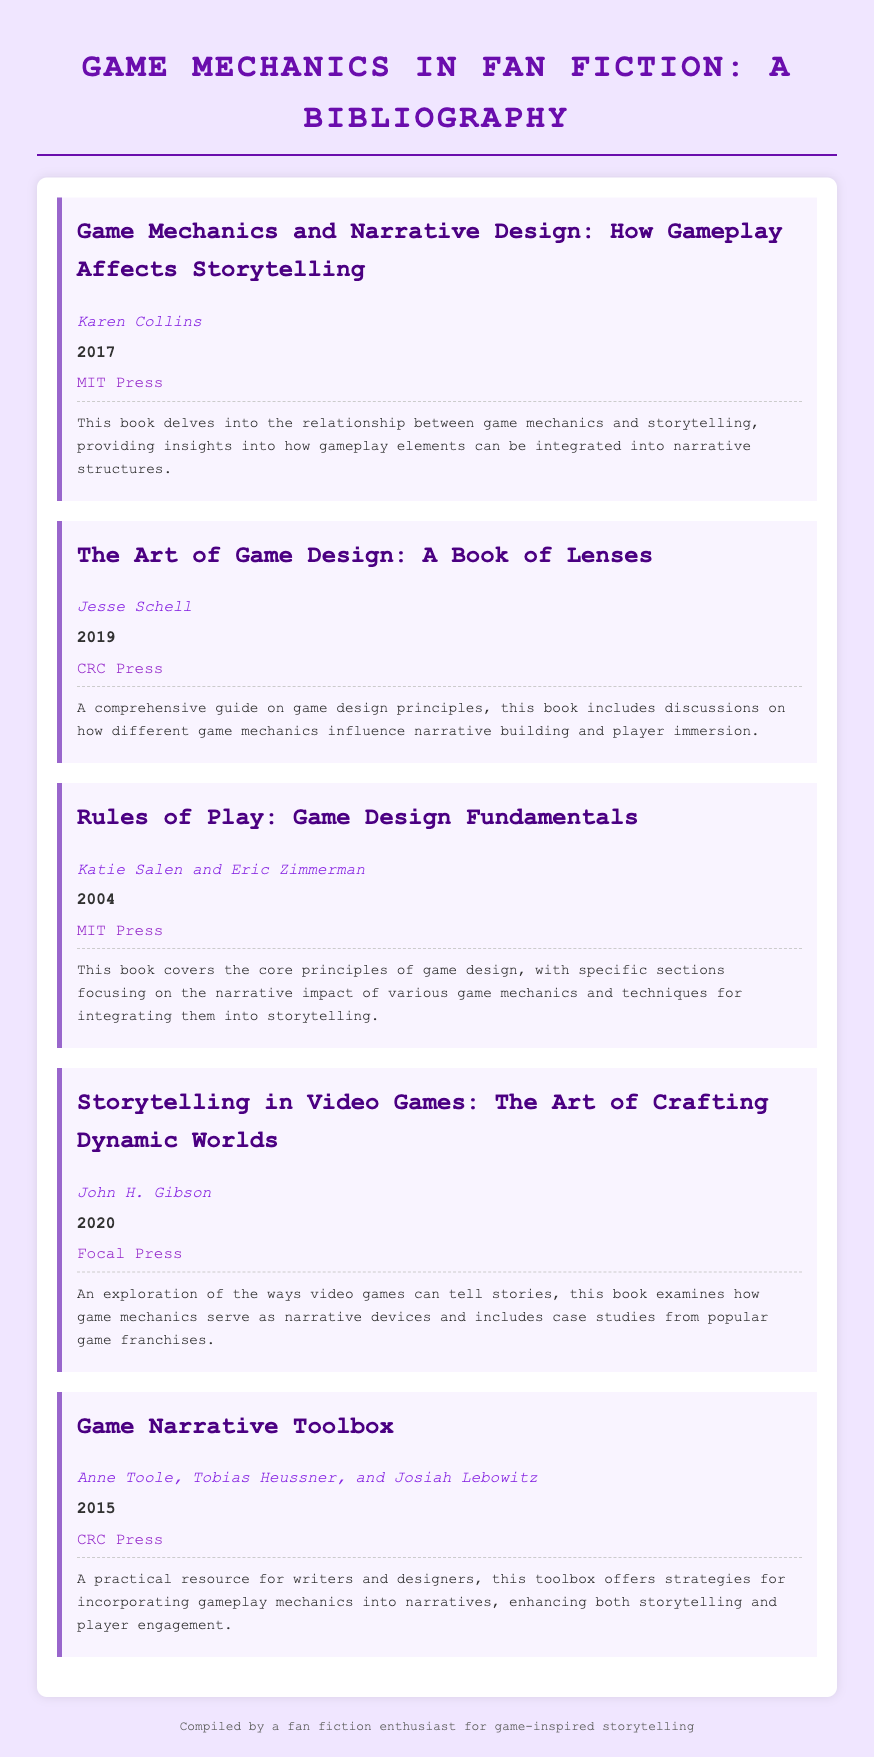What is the title of the first entry? The title of the first entry can be found in the bibliography section of the document.
Answer: Game Mechanics and Narrative Design: How Gameplay Affects Storytelling Who is the author of "The Art of Game Design: A Book of Lenses"? The author is listed under the second entry in the bibliography.
Answer: Jesse Schell What year was "Rules of Play: Game Design Fundamentals" published? The publication year is provided alongside the book title in the bibliography.
Answer: 2004 How many authors contributed to "Game Narrative Toolbox"? The number of authors can be found mentioned in the entry for that book.
Answer: Three What is the publisher of "Storytelling in Video Games"? The publisher's name is given in the entry for the book in the bibliography.
Answer: Focal Press Which book discusses the narrative impact of various game mechanics? This information can be inferred from the description of the relevant entry in the document.
Answer: Rules of Play: Game Design Fundamentals What is the primary focus of the bibliography as a whole? This can be determined by examining the titles and descriptions of the entries.
Answer: Game mechanics in fan fiction What type of resource is "Game Narrative Toolbox"? The type of resource can be identified from the description provided in the entry.
Answer: Practical resource 